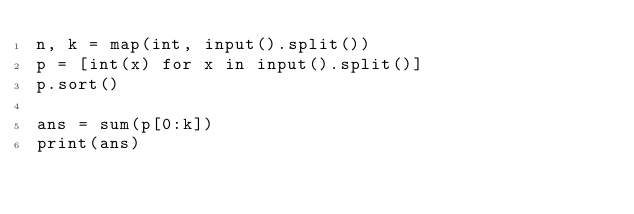Convert code to text. <code><loc_0><loc_0><loc_500><loc_500><_Python_>n, k = map(int, input().split())
p = [int(x) for x in input().split()]
p.sort()

ans = sum(p[0:k])
print(ans)
</code> 